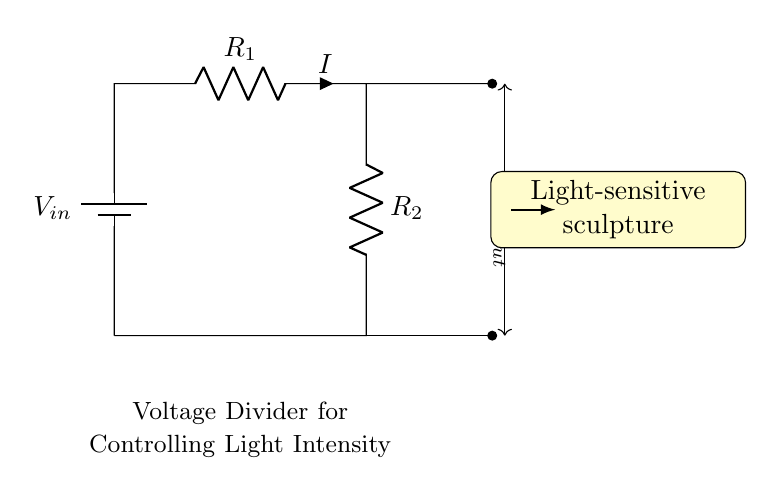What is the input voltage of this circuit? The input voltage is indicated as V_in, which is the voltage provided by the battery connected to the circuit.
Answer: V_in What components are in this circuit? The circuit consists of a battery, two resistors labeled as R_1 and R_2, and leads to show connections.
Answer: Battery, R_1, R_2 What does V_out represent in this circuit? V_out represents the output voltage that is taken between the two resistors R_1 and R_2. It is the voltage applied to the light-sensitive sculpture.
Answer: Output voltage How does increasing R_2 affect V_out? Increasing R_2 will increase the resistance in the voltage divider which results in a higher output voltage V_out since it changes the voltage distribution across R_1 and R_2.
Answer: Higher V_out What happens to the light-sensitive sculpture when V_out decreases? When V_out decreases, the intensity of the light-sensitive sculpture will dim as it receives less voltage, leading to less responsive behavior from the light-sensitive component.
Answer: It dims What is the relationship between R_1 and R_2 for desired brightness? The ratio of R_1 to R_2 determines the brightness of the light-sensitive sculpture. A more significant R_1 compared to R_2 will provide lower brightness, while a smaller R_1 compared to R_2 will provide higher brightness.
Answer: Ratio determines brightness 